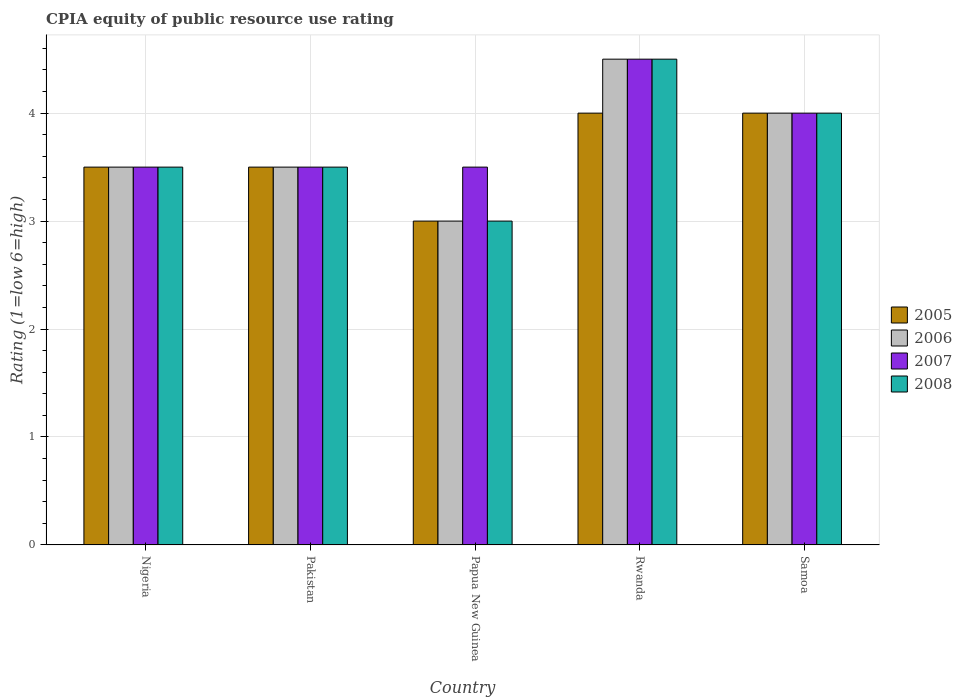Are the number of bars on each tick of the X-axis equal?
Your response must be concise. Yes. How many bars are there on the 1st tick from the right?
Give a very brief answer. 4. What is the label of the 1st group of bars from the left?
Offer a very short reply. Nigeria. In how many cases, is the number of bars for a given country not equal to the number of legend labels?
Offer a very short reply. 0. Across all countries, what is the maximum CPIA rating in 2006?
Give a very brief answer. 4.5. In which country was the CPIA rating in 2006 maximum?
Make the answer very short. Rwanda. In which country was the CPIA rating in 2008 minimum?
Keep it short and to the point. Papua New Guinea. What is the total CPIA rating in 2007 in the graph?
Give a very brief answer. 19. What is the difference between the CPIA rating in 2005 in Nigeria and the CPIA rating in 2006 in Papua New Guinea?
Provide a short and direct response. 0.5. What is the average CPIA rating in 2007 per country?
Provide a short and direct response. 3.8. In how many countries, is the CPIA rating in 2008 greater than 0.4?
Ensure brevity in your answer.  5. What is the ratio of the CPIA rating in 2005 in Nigeria to that in Rwanda?
Ensure brevity in your answer.  0.88. What is the difference between the highest and the second highest CPIA rating in 2007?
Offer a very short reply. -1. In how many countries, is the CPIA rating in 2005 greater than the average CPIA rating in 2005 taken over all countries?
Your answer should be compact. 2. Is the sum of the CPIA rating in 2005 in Pakistan and Samoa greater than the maximum CPIA rating in 2007 across all countries?
Your response must be concise. Yes. Is it the case that in every country, the sum of the CPIA rating in 2007 and CPIA rating in 2005 is greater than the sum of CPIA rating in 2008 and CPIA rating in 2006?
Your answer should be very brief. No. What does the 2nd bar from the left in Rwanda represents?
Offer a very short reply. 2006. What does the 3rd bar from the right in Samoa represents?
Your response must be concise. 2006. Are all the bars in the graph horizontal?
Give a very brief answer. No. What is the difference between two consecutive major ticks on the Y-axis?
Ensure brevity in your answer.  1. Does the graph contain any zero values?
Give a very brief answer. No. Does the graph contain grids?
Your answer should be compact. Yes. Where does the legend appear in the graph?
Provide a short and direct response. Center right. How are the legend labels stacked?
Keep it short and to the point. Vertical. What is the title of the graph?
Give a very brief answer. CPIA equity of public resource use rating. Does "1979" appear as one of the legend labels in the graph?
Your answer should be compact. No. What is the label or title of the X-axis?
Your answer should be very brief. Country. What is the label or title of the Y-axis?
Provide a succinct answer. Rating (1=low 6=high). What is the Rating (1=low 6=high) of 2008 in Nigeria?
Your response must be concise. 3.5. What is the Rating (1=low 6=high) in 2005 in Pakistan?
Offer a very short reply. 3.5. What is the Rating (1=low 6=high) of 2006 in Pakistan?
Offer a very short reply. 3.5. What is the Rating (1=low 6=high) in 2007 in Pakistan?
Provide a short and direct response. 3.5. What is the Rating (1=low 6=high) of 2005 in Papua New Guinea?
Provide a succinct answer. 3. What is the Rating (1=low 6=high) of 2008 in Papua New Guinea?
Offer a terse response. 3. What is the Rating (1=low 6=high) in 2005 in Rwanda?
Your answer should be very brief. 4. What is the Rating (1=low 6=high) in 2006 in Rwanda?
Your answer should be compact. 4.5. What is the Rating (1=low 6=high) of 2007 in Samoa?
Offer a very short reply. 4. What is the Rating (1=low 6=high) in 2008 in Samoa?
Ensure brevity in your answer.  4. Across all countries, what is the maximum Rating (1=low 6=high) in 2005?
Provide a succinct answer. 4. Across all countries, what is the maximum Rating (1=low 6=high) of 2006?
Ensure brevity in your answer.  4.5. Across all countries, what is the minimum Rating (1=low 6=high) of 2005?
Provide a short and direct response. 3. Across all countries, what is the minimum Rating (1=low 6=high) in 2006?
Your answer should be very brief. 3. Across all countries, what is the minimum Rating (1=low 6=high) in 2007?
Keep it short and to the point. 3.5. Across all countries, what is the minimum Rating (1=low 6=high) of 2008?
Your answer should be compact. 3. What is the total Rating (1=low 6=high) of 2008 in the graph?
Your answer should be very brief. 18.5. What is the difference between the Rating (1=low 6=high) in 2005 in Nigeria and that in Pakistan?
Offer a very short reply. 0. What is the difference between the Rating (1=low 6=high) of 2006 in Nigeria and that in Pakistan?
Offer a very short reply. 0. What is the difference between the Rating (1=low 6=high) of 2006 in Nigeria and that in Papua New Guinea?
Your answer should be compact. 0.5. What is the difference between the Rating (1=low 6=high) of 2007 in Nigeria and that in Papua New Guinea?
Ensure brevity in your answer.  0. What is the difference between the Rating (1=low 6=high) of 2008 in Nigeria and that in Papua New Guinea?
Your response must be concise. 0.5. What is the difference between the Rating (1=low 6=high) in 2005 in Nigeria and that in Rwanda?
Offer a very short reply. -0.5. What is the difference between the Rating (1=low 6=high) in 2005 in Nigeria and that in Samoa?
Keep it short and to the point. -0.5. What is the difference between the Rating (1=low 6=high) in 2007 in Nigeria and that in Samoa?
Offer a very short reply. -0.5. What is the difference between the Rating (1=low 6=high) in 2008 in Nigeria and that in Samoa?
Offer a very short reply. -0.5. What is the difference between the Rating (1=low 6=high) of 2005 in Pakistan and that in Papua New Guinea?
Keep it short and to the point. 0.5. What is the difference between the Rating (1=low 6=high) in 2007 in Pakistan and that in Rwanda?
Make the answer very short. -1. What is the difference between the Rating (1=low 6=high) in 2008 in Pakistan and that in Samoa?
Your response must be concise. -0.5. What is the difference between the Rating (1=low 6=high) of 2005 in Papua New Guinea and that in Rwanda?
Your answer should be very brief. -1. What is the difference between the Rating (1=low 6=high) of 2005 in Papua New Guinea and that in Samoa?
Offer a terse response. -1. What is the difference between the Rating (1=low 6=high) in 2007 in Papua New Guinea and that in Samoa?
Your response must be concise. -0.5. What is the difference between the Rating (1=low 6=high) of 2008 in Papua New Guinea and that in Samoa?
Make the answer very short. -1. What is the difference between the Rating (1=low 6=high) of 2005 in Rwanda and that in Samoa?
Your answer should be compact. 0. What is the difference between the Rating (1=low 6=high) in 2007 in Rwanda and that in Samoa?
Your answer should be compact. 0.5. What is the difference between the Rating (1=low 6=high) in 2008 in Rwanda and that in Samoa?
Keep it short and to the point. 0.5. What is the difference between the Rating (1=low 6=high) in 2005 in Nigeria and the Rating (1=low 6=high) in 2006 in Pakistan?
Keep it short and to the point. 0. What is the difference between the Rating (1=low 6=high) in 2005 in Nigeria and the Rating (1=low 6=high) in 2007 in Pakistan?
Keep it short and to the point. 0. What is the difference between the Rating (1=low 6=high) in 2006 in Nigeria and the Rating (1=low 6=high) in 2007 in Pakistan?
Offer a terse response. 0. What is the difference between the Rating (1=low 6=high) in 2007 in Nigeria and the Rating (1=low 6=high) in 2008 in Pakistan?
Provide a short and direct response. 0. What is the difference between the Rating (1=low 6=high) of 2005 in Nigeria and the Rating (1=low 6=high) of 2006 in Papua New Guinea?
Provide a short and direct response. 0.5. What is the difference between the Rating (1=low 6=high) of 2005 in Nigeria and the Rating (1=low 6=high) of 2007 in Papua New Guinea?
Offer a very short reply. 0. What is the difference between the Rating (1=low 6=high) of 2006 in Nigeria and the Rating (1=low 6=high) of 2008 in Papua New Guinea?
Provide a short and direct response. 0.5. What is the difference between the Rating (1=low 6=high) in 2007 in Nigeria and the Rating (1=low 6=high) in 2008 in Papua New Guinea?
Your response must be concise. 0.5. What is the difference between the Rating (1=low 6=high) in 2005 in Nigeria and the Rating (1=low 6=high) in 2007 in Rwanda?
Your answer should be compact. -1. What is the difference between the Rating (1=low 6=high) of 2006 in Nigeria and the Rating (1=low 6=high) of 2007 in Rwanda?
Offer a terse response. -1. What is the difference between the Rating (1=low 6=high) in 2007 in Nigeria and the Rating (1=low 6=high) in 2008 in Samoa?
Give a very brief answer. -0.5. What is the difference between the Rating (1=low 6=high) of 2005 in Pakistan and the Rating (1=low 6=high) of 2008 in Papua New Guinea?
Your response must be concise. 0.5. What is the difference between the Rating (1=low 6=high) of 2005 in Pakistan and the Rating (1=low 6=high) of 2006 in Rwanda?
Provide a succinct answer. -1. What is the difference between the Rating (1=low 6=high) in 2006 in Pakistan and the Rating (1=low 6=high) in 2007 in Rwanda?
Ensure brevity in your answer.  -1. What is the difference between the Rating (1=low 6=high) of 2007 in Pakistan and the Rating (1=low 6=high) of 2008 in Rwanda?
Provide a short and direct response. -1. What is the difference between the Rating (1=low 6=high) of 2006 in Pakistan and the Rating (1=low 6=high) of 2008 in Samoa?
Offer a terse response. -0.5. What is the difference between the Rating (1=low 6=high) of 2007 in Pakistan and the Rating (1=low 6=high) of 2008 in Samoa?
Make the answer very short. -0.5. What is the difference between the Rating (1=low 6=high) in 2005 in Papua New Guinea and the Rating (1=low 6=high) in 2006 in Rwanda?
Keep it short and to the point. -1.5. What is the difference between the Rating (1=low 6=high) of 2005 in Papua New Guinea and the Rating (1=low 6=high) of 2007 in Rwanda?
Keep it short and to the point. -1.5. What is the difference between the Rating (1=low 6=high) in 2006 in Papua New Guinea and the Rating (1=low 6=high) in 2007 in Rwanda?
Provide a succinct answer. -1.5. What is the difference between the Rating (1=low 6=high) in 2005 in Papua New Guinea and the Rating (1=low 6=high) in 2006 in Samoa?
Your answer should be very brief. -1. What is the difference between the Rating (1=low 6=high) of 2005 in Papua New Guinea and the Rating (1=low 6=high) of 2007 in Samoa?
Your answer should be compact. -1. What is the difference between the Rating (1=low 6=high) in 2005 in Papua New Guinea and the Rating (1=low 6=high) in 2008 in Samoa?
Keep it short and to the point. -1. What is the difference between the Rating (1=low 6=high) of 2006 in Rwanda and the Rating (1=low 6=high) of 2007 in Samoa?
Give a very brief answer. 0.5. What is the difference between the Rating (1=low 6=high) in 2006 in Rwanda and the Rating (1=low 6=high) in 2008 in Samoa?
Give a very brief answer. 0.5. What is the average Rating (1=low 6=high) of 2006 per country?
Offer a very short reply. 3.7. What is the difference between the Rating (1=low 6=high) of 2005 and Rating (1=low 6=high) of 2008 in Nigeria?
Offer a very short reply. 0. What is the difference between the Rating (1=low 6=high) of 2006 and Rating (1=low 6=high) of 2007 in Nigeria?
Offer a terse response. 0. What is the difference between the Rating (1=low 6=high) of 2006 and Rating (1=low 6=high) of 2008 in Nigeria?
Ensure brevity in your answer.  0. What is the difference between the Rating (1=low 6=high) of 2007 and Rating (1=low 6=high) of 2008 in Nigeria?
Offer a very short reply. 0. What is the difference between the Rating (1=low 6=high) of 2005 and Rating (1=low 6=high) of 2006 in Pakistan?
Your response must be concise. 0. What is the difference between the Rating (1=low 6=high) in 2005 and Rating (1=low 6=high) in 2008 in Pakistan?
Your answer should be very brief. 0. What is the difference between the Rating (1=low 6=high) of 2006 and Rating (1=low 6=high) of 2007 in Pakistan?
Make the answer very short. 0. What is the difference between the Rating (1=low 6=high) in 2005 and Rating (1=low 6=high) in 2008 in Papua New Guinea?
Ensure brevity in your answer.  0. What is the difference between the Rating (1=low 6=high) of 2006 and Rating (1=low 6=high) of 2007 in Papua New Guinea?
Offer a terse response. -0.5. What is the difference between the Rating (1=low 6=high) in 2007 and Rating (1=low 6=high) in 2008 in Papua New Guinea?
Offer a terse response. 0.5. What is the difference between the Rating (1=low 6=high) in 2005 and Rating (1=low 6=high) in 2006 in Rwanda?
Offer a very short reply. -0.5. What is the difference between the Rating (1=low 6=high) in 2005 and Rating (1=low 6=high) in 2007 in Rwanda?
Provide a short and direct response. -0.5. What is the difference between the Rating (1=low 6=high) in 2006 and Rating (1=low 6=high) in 2007 in Rwanda?
Offer a very short reply. 0. What is the difference between the Rating (1=low 6=high) of 2005 and Rating (1=low 6=high) of 2006 in Samoa?
Your response must be concise. 0. What is the difference between the Rating (1=low 6=high) of 2005 and Rating (1=low 6=high) of 2007 in Samoa?
Offer a very short reply. 0. What is the difference between the Rating (1=low 6=high) in 2005 and Rating (1=low 6=high) in 2008 in Samoa?
Your answer should be very brief. 0. What is the difference between the Rating (1=low 6=high) of 2006 and Rating (1=low 6=high) of 2007 in Samoa?
Offer a terse response. 0. What is the difference between the Rating (1=low 6=high) of 2006 and Rating (1=low 6=high) of 2008 in Samoa?
Your response must be concise. 0. What is the ratio of the Rating (1=low 6=high) in 2006 in Nigeria to that in Pakistan?
Ensure brevity in your answer.  1. What is the ratio of the Rating (1=low 6=high) in 2008 in Nigeria to that in Pakistan?
Provide a short and direct response. 1. What is the ratio of the Rating (1=low 6=high) of 2008 in Nigeria to that in Papua New Guinea?
Your answer should be very brief. 1.17. What is the ratio of the Rating (1=low 6=high) of 2005 in Nigeria to that in Rwanda?
Keep it short and to the point. 0.88. What is the ratio of the Rating (1=low 6=high) in 2006 in Nigeria to that in Rwanda?
Your answer should be very brief. 0.78. What is the ratio of the Rating (1=low 6=high) of 2007 in Nigeria to that in Rwanda?
Offer a terse response. 0.78. What is the ratio of the Rating (1=low 6=high) of 2008 in Nigeria to that in Rwanda?
Keep it short and to the point. 0.78. What is the ratio of the Rating (1=low 6=high) of 2006 in Nigeria to that in Samoa?
Give a very brief answer. 0.88. What is the ratio of the Rating (1=low 6=high) in 2005 in Pakistan to that in Papua New Guinea?
Keep it short and to the point. 1.17. What is the ratio of the Rating (1=low 6=high) of 2008 in Pakistan to that in Papua New Guinea?
Provide a succinct answer. 1.17. What is the ratio of the Rating (1=low 6=high) of 2007 in Pakistan to that in Rwanda?
Offer a very short reply. 0.78. What is the ratio of the Rating (1=low 6=high) in 2006 in Pakistan to that in Samoa?
Your answer should be compact. 0.88. What is the ratio of the Rating (1=low 6=high) of 2008 in Pakistan to that in Samoa?
Ensure brevity in your answer.  0.88. What is the ratio of the Rating (1=low 6=high) in 2005 in Papua New Guinea to that in Rwanda?
Your answer should be compact. 0.75. What is the ratio of the Rating (1=low 6=high) in 2006 in Papua New Guinea to that in Rwanda?
Give a very brief answer. 0.67. What is the ratio of the Rating (1=low 6=high) in 2008 in Papua New Guinea to that in Rwanda?
Offer a very short reply. 0.67. What is the ratio of the Rating (1=low 6=high) in 2007 in Papua New Guinea to that in Samoa?
Keep it short and to the point. 0.88. What is the ratio of the Rating (1=low 6=high) in 2006 in Rwanda to that in Samoa?
Provide a succinct answer. 1.12. What is the ratio of the Rating (1=low 6=high) of 2007 in Rwanda to that in Samoa?
Your answer should be compact. 1.12. What is the difference between the highest and the second highest Rating (1=low 6=high) in 2006?
Offer a very short reply. 0.5. What is the difference between the highest and the second highest Rating (1=low 6=high) of 2007?
Ensure brevity in your answer.  0.5. What is the difference between the highest and the lowest Rating (1=low 6=high) in 2008?
Your answer should be compact. 1.5. 